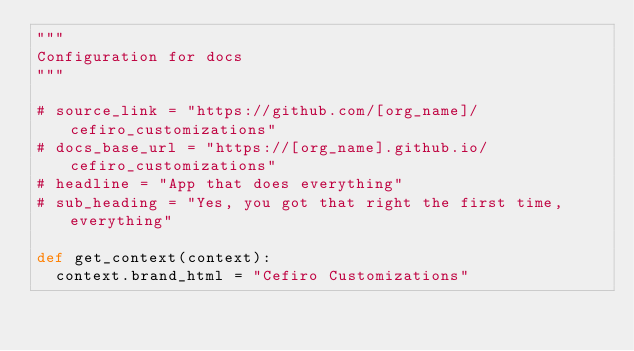<code> <loc_0><loc_0><loc_500><loc_500><_Python_>"""
Configuration for docs
"""

# source_link = "https://github.com/[org_name]/cefiro_customizations"
# docs_base_url = "https://[org_name].github.io/cefiro_customizations"
# headline = "App that does everything"
# sub_heading = "Yes, you got that right the first time, everything"

def get_context(context):
	context.brand_html = "Cefiro Customizations"
</code> 